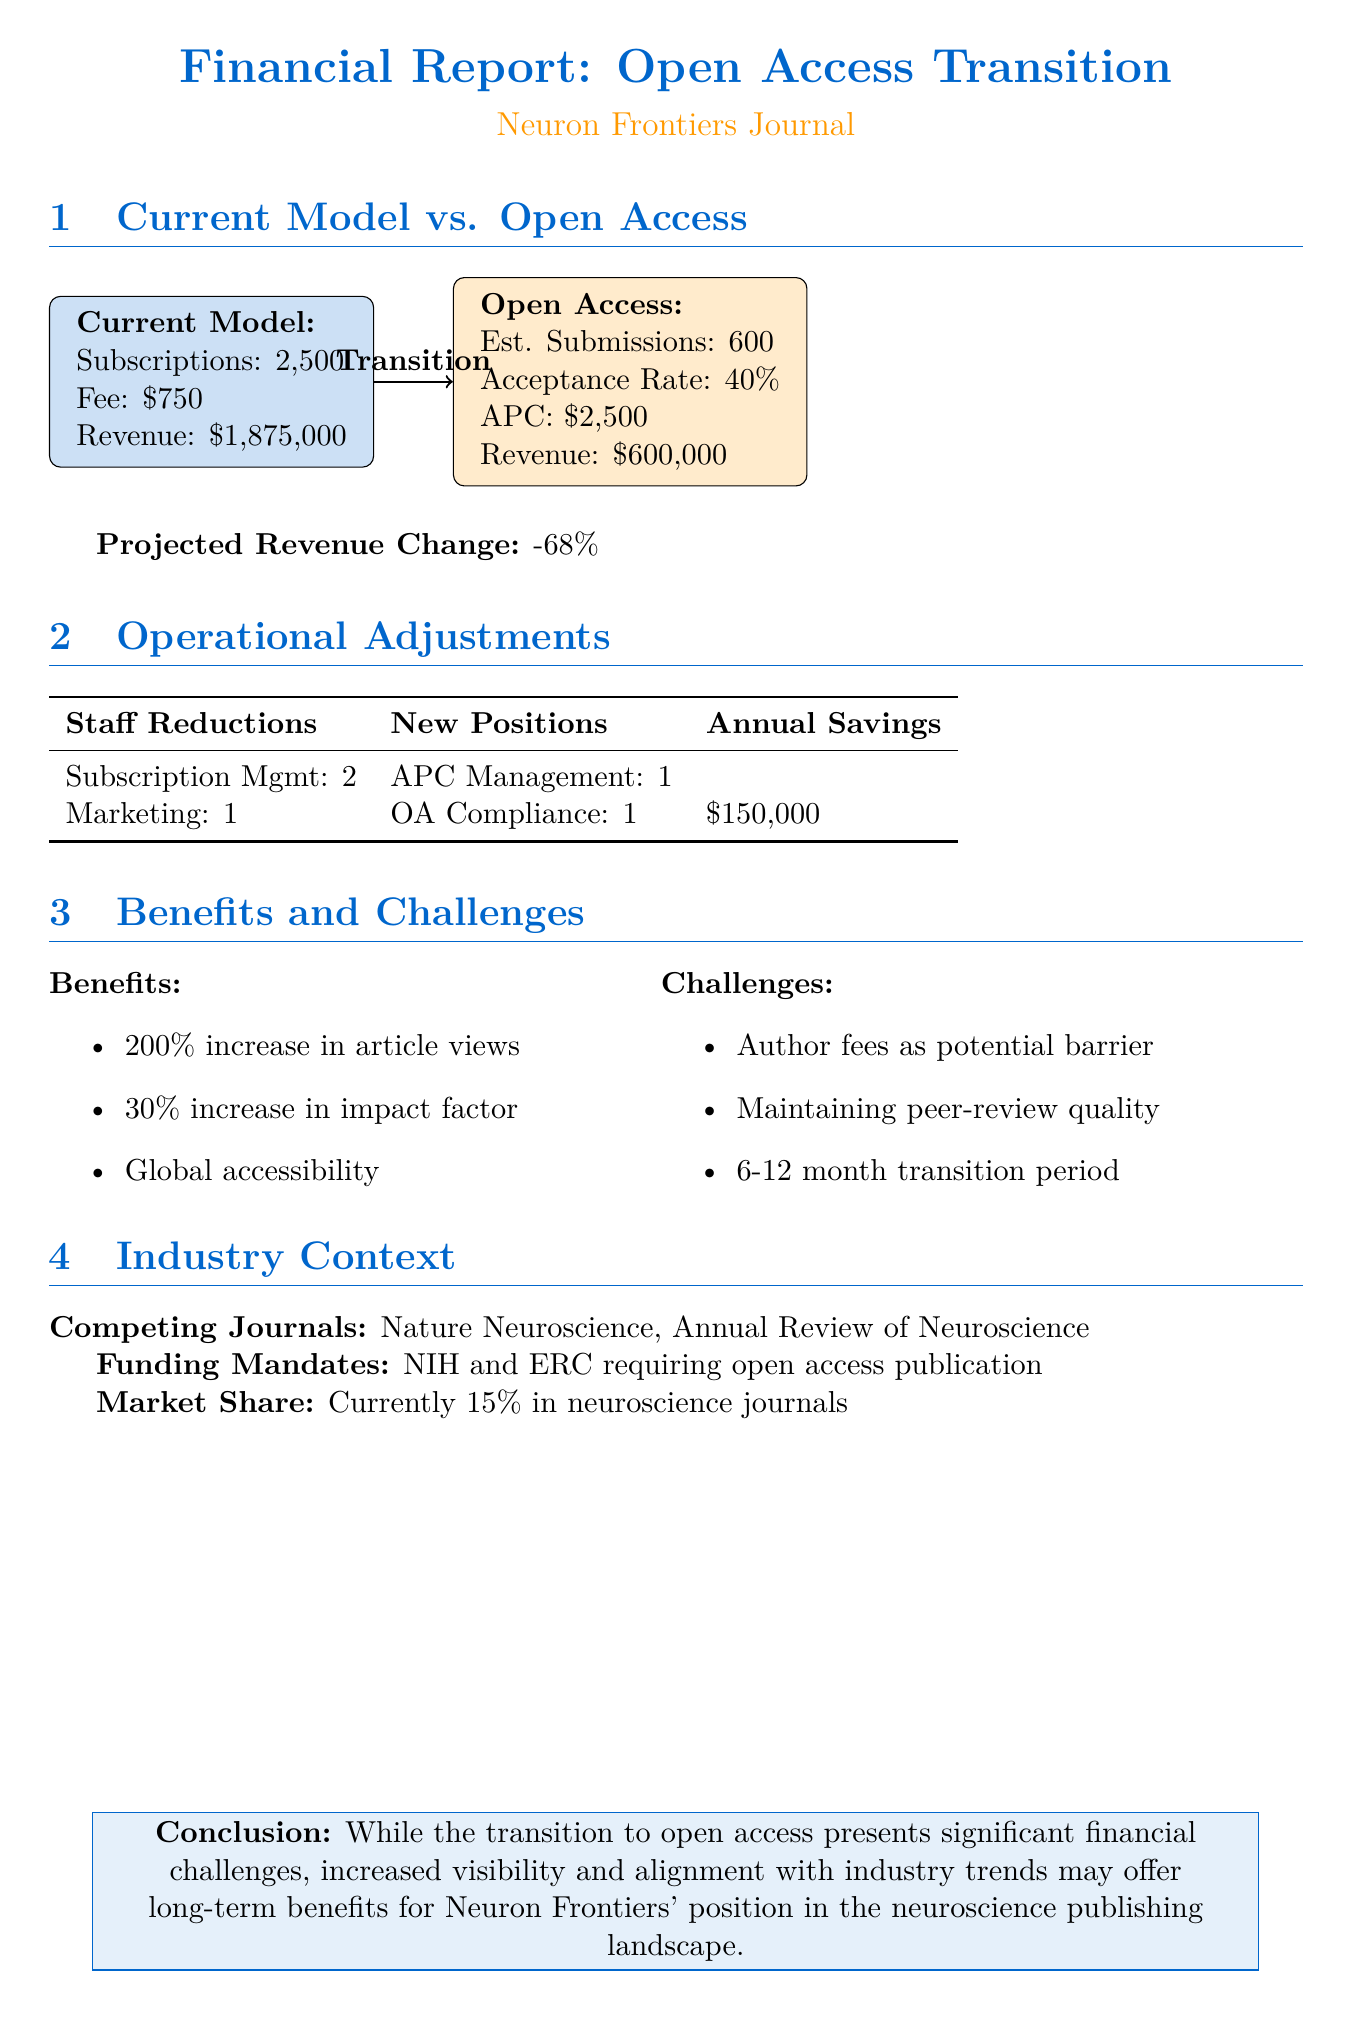What is the current subscription fee? The document states the current subscription fee is $750.
Answer: $750 How many estimated annual submissions are projected under the open access model? The document mentions an estimated annual submission of 600 under the open access model.
Answer: 600 What is the projected acceptance rate for the open access submissions? The projected acceptance rate for the open access submissions is mentioned as 40%.
Answer: 40% What is the total projected annual revenue for the open access model? The document provides a projected open access revenue of $600,000.
Answer: $600,000 How much is the estimated revenue change when transitioning to open access? The document indicates an estimated revenue change of -68%.
Answer: -68% What are the projected annual savings from operational adjustments? The document states the projected annual savings from adjustments will be $150,000.
Answer: $150,000 Which organizations are requiring open access publication according to industry trends? The funding body mandates list NIH and ERC as requiring open access publication.
Answer: NIH and ERC What percentage increase in article views is expected with the open access model? The expected increase in article views is indicated as 200%.
Answer: 200% What is the current market share of Neuron Frontiers in neuroscience journals? The document states that the current market share is 15%.
Answer: 15% 